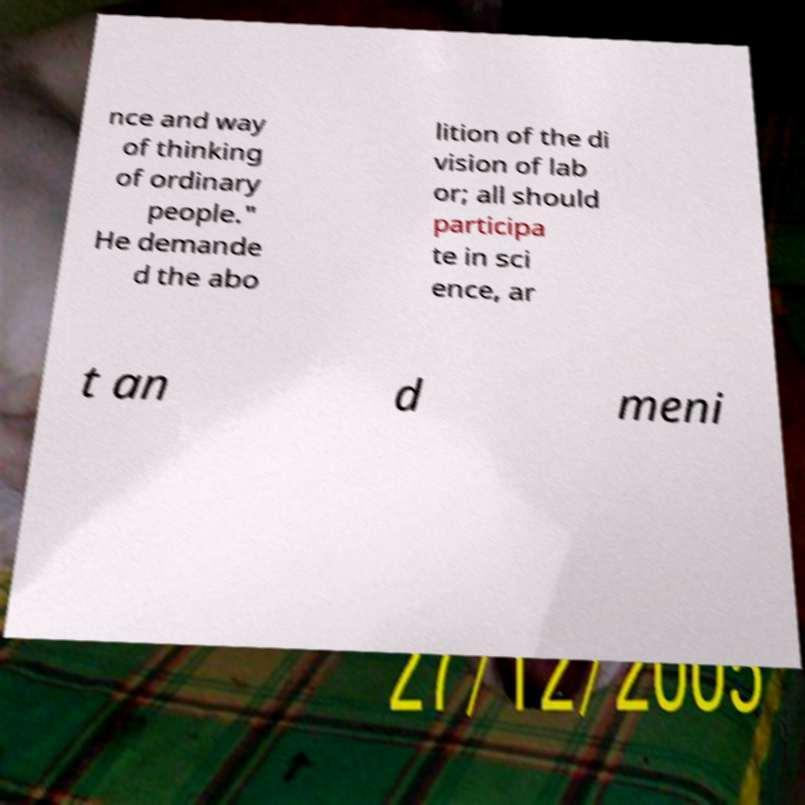There's text embedded in this image that I need extracted. Can you transcribe it verbatim? nce and way of thinking of ordinary people." He demande d the abo lition of the di vision of lab or; all should participa te in sci ence, ar t an d meni 